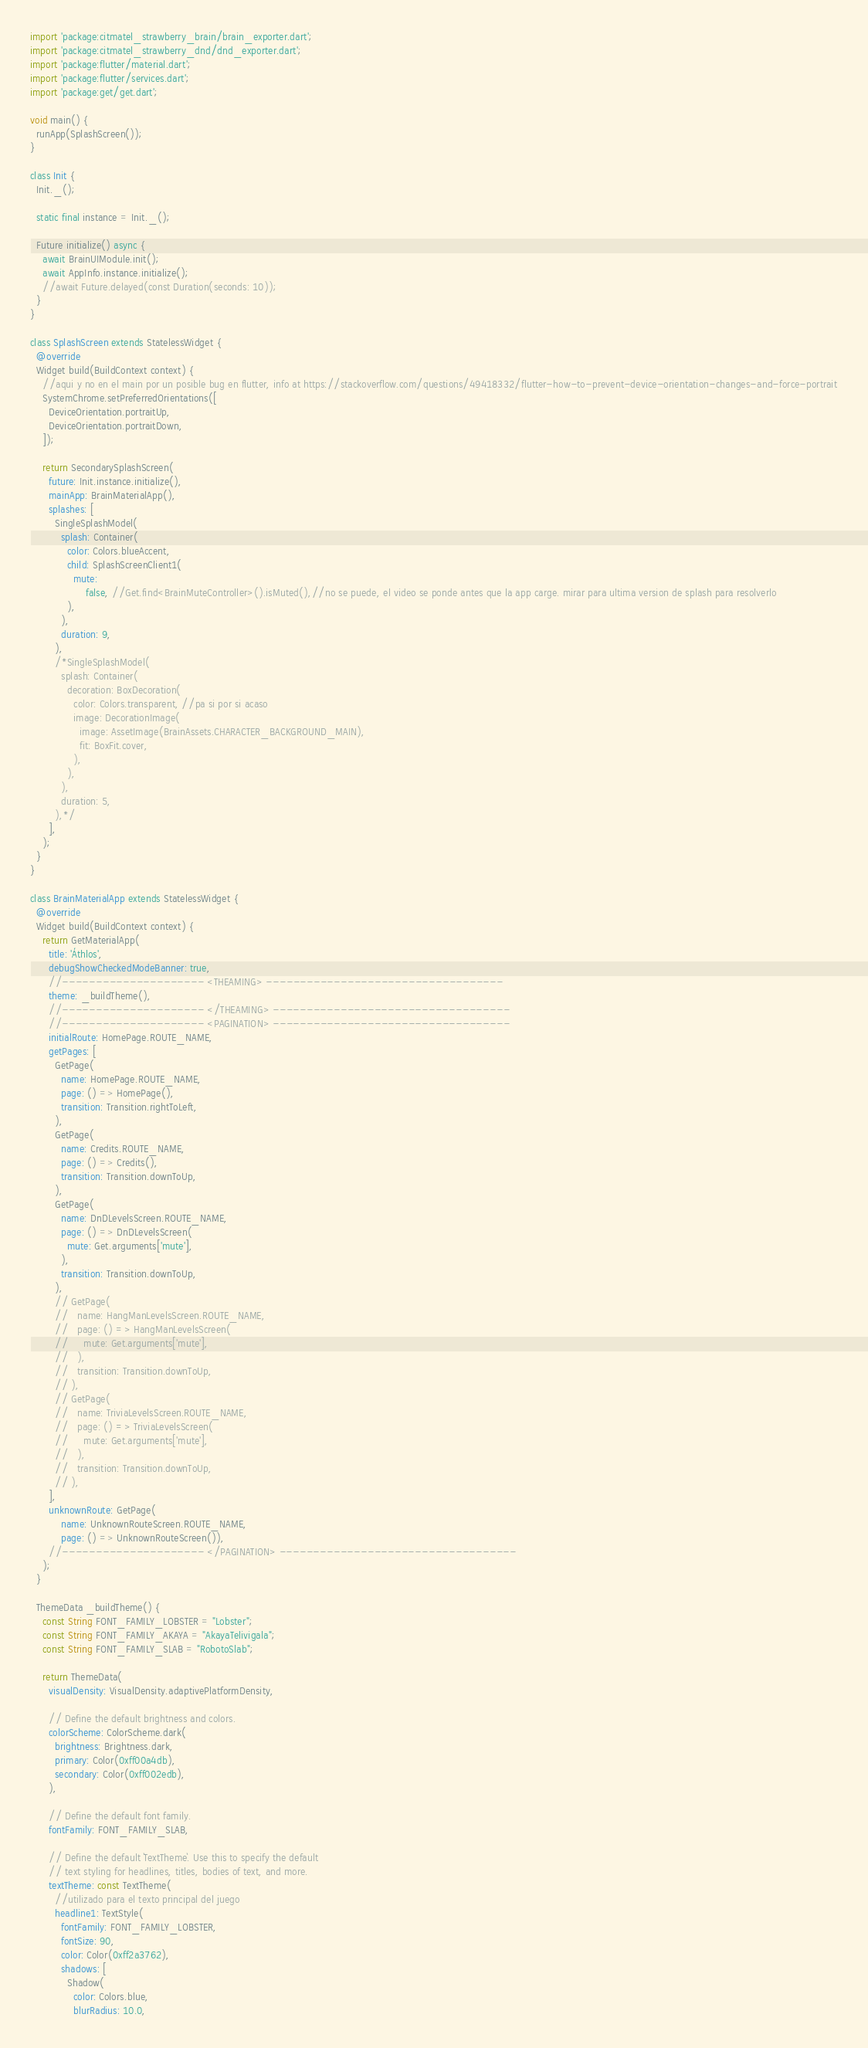<code> <loc_0><loc_0><loc_500><loc_500><_Dart_>import 'package:citmatel_strawberry_brain/brain_exporter.dart';
import 'package:citmatel_strawberry_dnd/dnd_exporter.dart';
import 'package:flutter/material.dart';
import 'package:flutter/services.dart';
import 'package:get/get.dart';

void main() {
  runApp(SplashScreen());
}

class Init {
  Init._();

  static final instance = Init._();

  Future initialize() async {
    await BrainUIModule.init();
    await AppInfo.instance.initialize();
    //await Future.delayed(const Duration(seconds: 10));
  }
}

class SplashScreen extends StatelessWidget {
  @override
  Widget build(BuildContext context) {
    //aqui y no en el main por un posible bug en flutter, info at https://stackoverflow.com/questions/49418332/flutter-how-to-prevent-device-orientation-changes-and-force-portrait
    SystemChrome.setPreferredOrientations([
      DeviceOrientation.portraitUp,
      DeviceOrientation.portraitDown,
    ]);

    return SecondarySplashScreen(
      future: Init.instance.initialize(),
      mainApp: BrainMaterialApp(),
      splashes: [
        SingleSplashModel(
          splash: Container(
            color: Colors.blueAccent,
            child: SplashScreenClient1(
              mute:
                  false, //Get.find<BrainMuteController>().isMuted(),//no se puede, el video se ponde antes que la app carge. mirar para ultima version de splash para resolverlo
            ),
          ),
          duration: 9,
        ),
        /*SingleSplashModel(
          splash: Container(
            decoration: BoxDecoration(
              color: Colors.transparent, //pa si por si acaso
              image: DecorationImage(
                image: AssetImage(BrainAssets.CHARACTER_BACKGROUND_MAIN),
                fit: BoxFit.cover,
              ),
            ),
          ),
          duration: 5,
        ),*/
      ],
    );
  }
}

class BrainMaterialApp extends StatelessWidget {
  @override
  Widget build(BuildContext context) {
    return GetMaterialApp(
      title: 'Áthlos',
      debugShowCheckedModeBanner: true,
      //--------------------- <THEAMING> -----------------------------------
      theme: _buildTheme(),
      //--------------------- </THEAMING> -----------------------------------
      //--------------------- <PAGINATION> -----------------------------------
      initialRoute: HomePage.ROUTE_NAME,
      getPages: [
        GetPage(
          name: HomePage.ROUTE_NAME,
          page: () => HomePage(),
          transition: Transition.rightToLeft,
        ),
        GetPage(
          name: Credits.ROUTE_NAME,
          page: () => Credits(),
          transition: Transition.downToUp,
        ),
        GetPage(
          name: DnDLevelsScreen.ROUTE_NAME,
          page: () => DnDLevelsScreen(
            mute: Get.arguments['mute'],
          ),
          transition: Transition.downToUp,
        ),
        // GetPage(
        //   name: HangManLevelsScreen.ROUTE_NAME,
        //   page: () => HangManLevelsScreen(
        //     mute: Get.arguments['mute'],
        //   ),
        //   transition: Transition.downToUp,
        // ),
        // GetPage(
        //   name: TriviaLevelsScreen.ROUTE_NAME,
        //   page: () => TriviaLevelsScreen(
        //     mute: Get.arguments['mute'],
        //   ),
        //   transition: Transition.downToUp,
        // ),
      ],
      unknownRoute: GetPage(
          name: UnknownRouteScreen.ROUTE_NAME,
          page: () => UnknownRouteScreen()),
      //--------------------- </PAGINATION> -----------------------------------
    );
  }

  ThemeData _buildTheme() {
    const String FONT_FAMILY_LOBSTER = "Lobster";
    const String FONT_FAMILY_AKAYA = "AkayaTelivigala";
    const String FONT_FAMILY_SLAB = "RobotoSlab";

    return ThemeData(
      visualDensity: VisualDensity.adaptivePlatformDensity,

      // Define the default brightness and colors.
      colorScheme: ColorScheme.dark(
        brightness: Brightness.dark,
        primary: Color(0xff00a4db),
        secondary: Color(0xff002edb),
      ),

      // Define the default font family.
      fontFamily: FONT_FAMILY_SLAB,

      // Define the default `TextTheme`. Use this to specify the default
      // text styling for headlines, titles, bodies of text, and more.
      textTheme: const TextTheme(
        //utilizado para el texto principal del juego
        headline1: TextStyle(
          fontFamily: FONT_FAMILY_LOBSTER,
          fontSize: 90,
          color: Color(0xff2a3762),
          shadows: [
            Shadow(
              color: Colors.blue,
              blurRadius: 10.0,</code> 